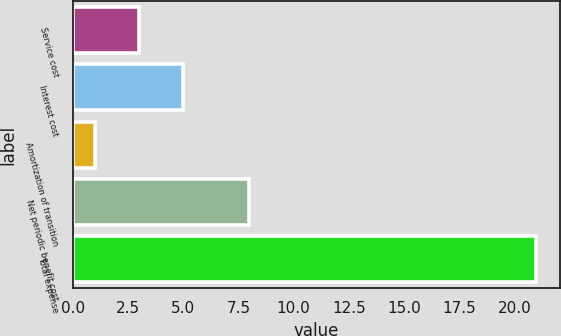<chart> <loc_0><loc_0><loc_500><loc_500><bar_chart><fcel>Service cost<fcel>Interest cost<fcel>Amortization of transition<fcel>Net periodic benefit cost<fcel>Total expense<nl><fcel>3<fcel>5<fcel>1<fcel>8<fcel>21<nl></chart> 